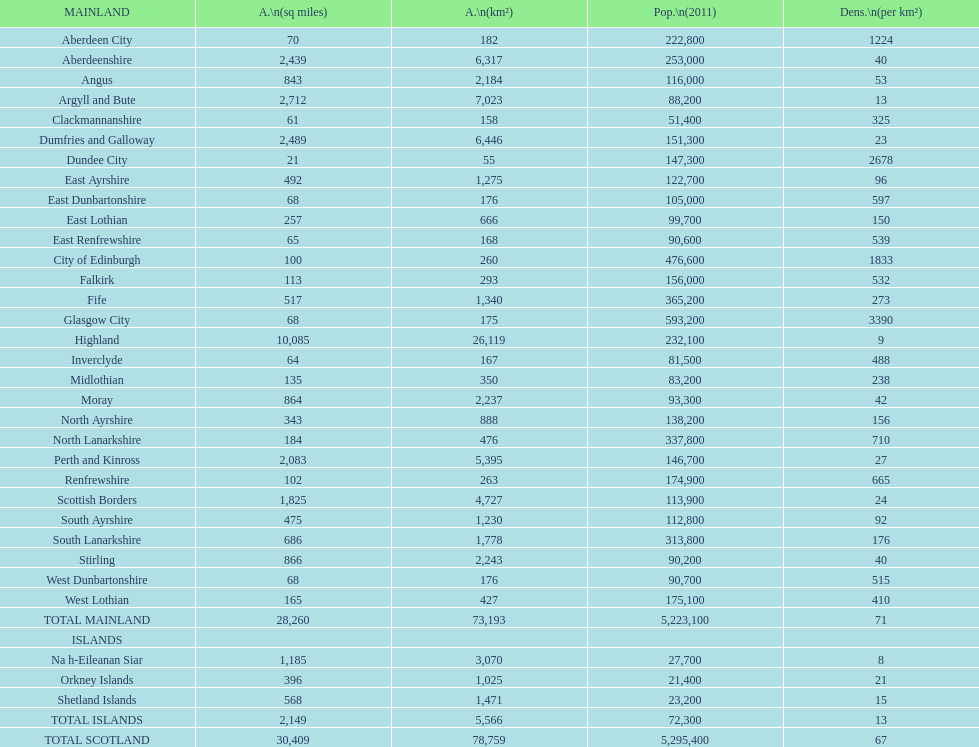Which is the only subdivision to have a greater area than argyll and bute? Highland. 